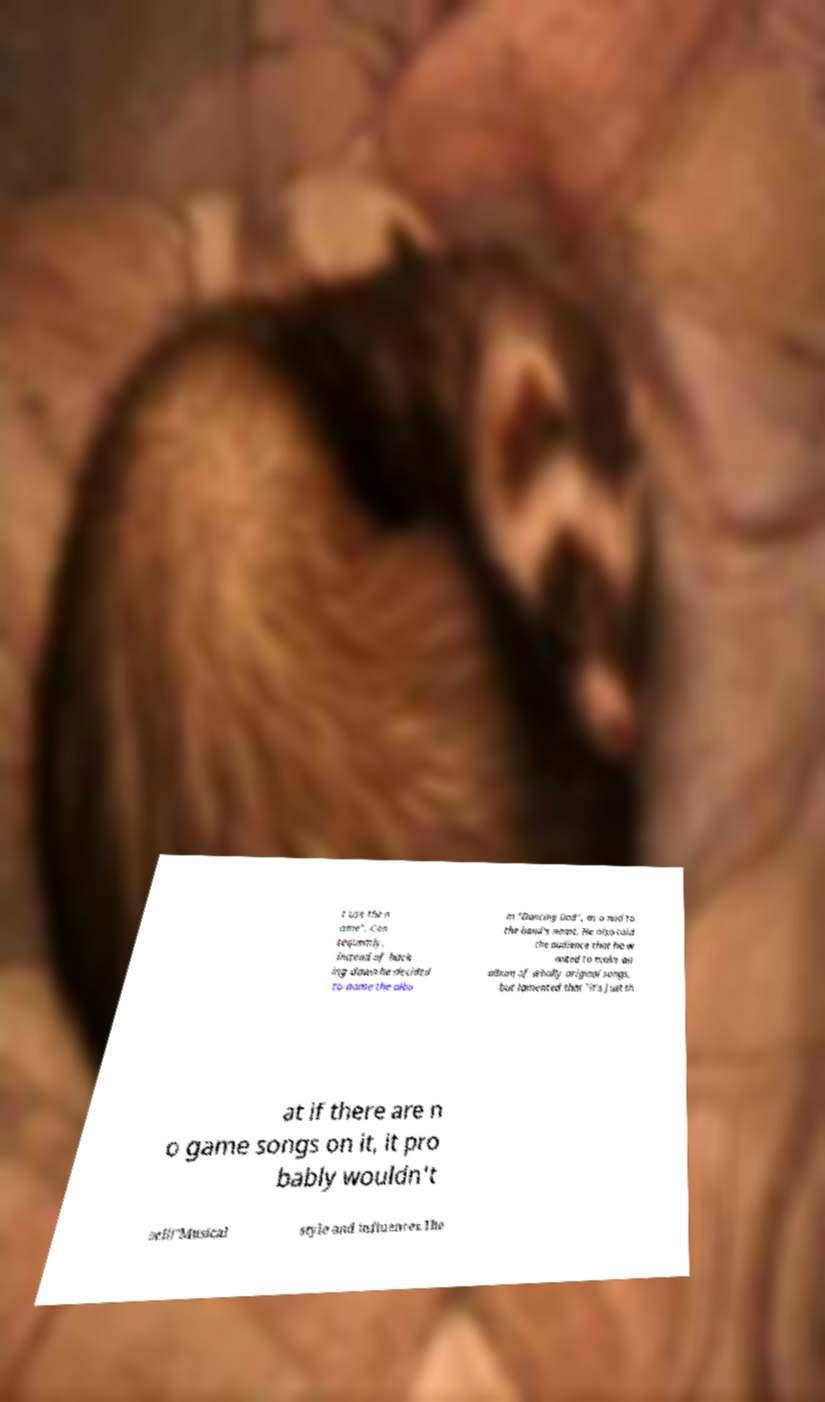Can you read and provide the text displayed in the image?This photo seems to have some interesting text. Can you extract and type it out for me? t use the n ame". Con sequently, instead of back ing down he decided to name the albu m "Dancing Dad", as a nod to the band's name. He also told the audience that he w anted to make an album of wholly original songs, but lamented that "it's just th at if there are n o game songs on it, it pro bably wouldn't sell!"Musical style and influences.The 